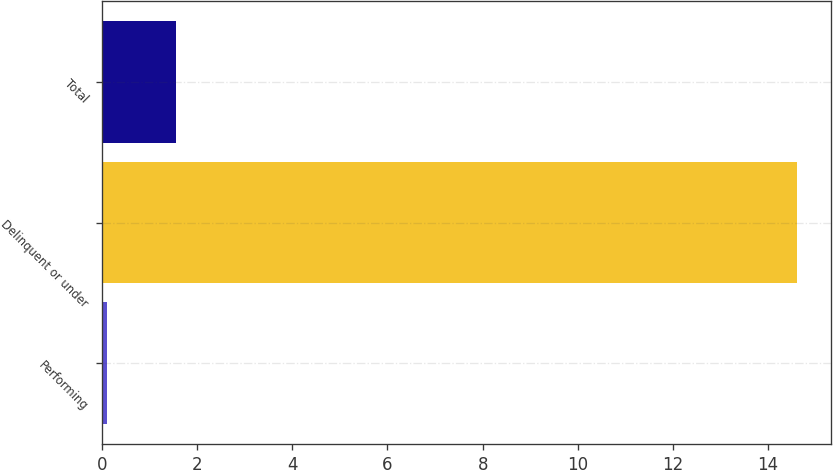Convert chart. <chart><loc_0><loc_0><loc_500><loc_500><bar_chart><fcel>Performing<fcel>Delinquent or under<fcel>Total<nl><fcel>0.1<fcel>14.6<fcel>1.55<nl></chart> 